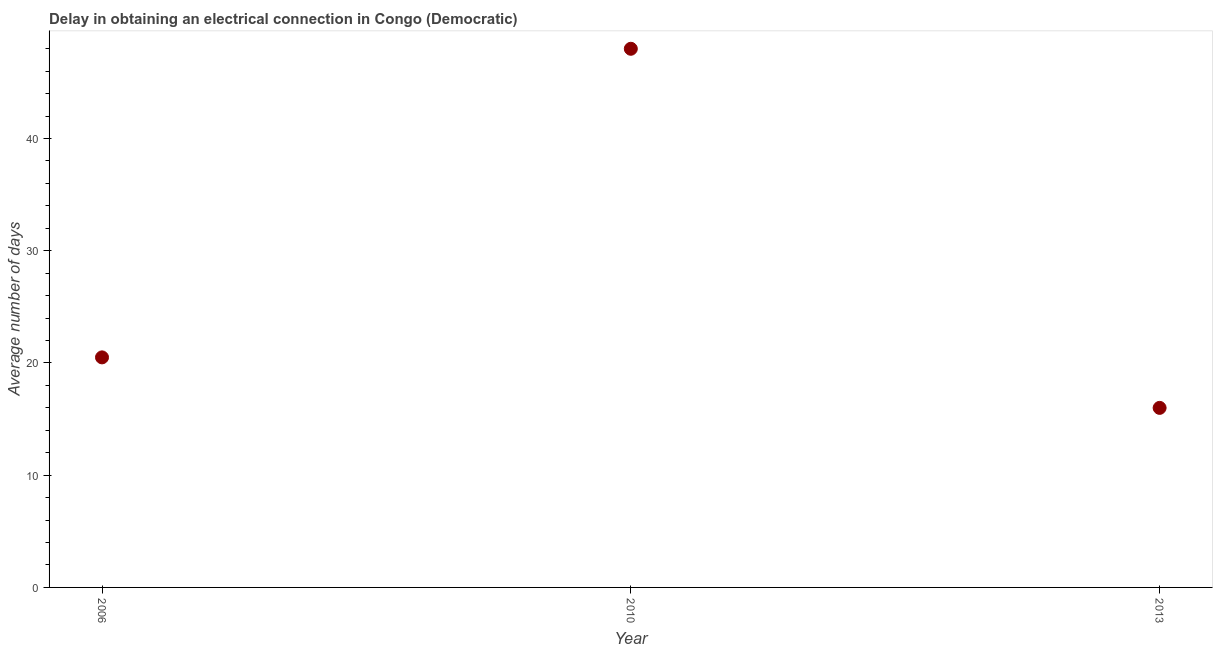What is the dalay in electrical connection in 2013?
Keep it short and to the point. 16. In which year was the dalay in electrical connection minimum?
Ensure brevity in your answer.  2013. What is the sum of the dalay in electrical connection?
Offer a very short reply. 84.5. What is the average dalay in electrical connection per year?
Give a very brief answer. 28.17. Is the dalay in electrical connection in 2006 less than that in 2013?
Keep it short and to the point. No. Is the difference between the dalay in electrical connection in 2006 and 2010 greater than the difference between any two years?
Give a very brief answer. No. What is the difference between the highest and the second highest dalay in electrical connection?
Keep it short and to the point. 27.5. What is the difference between the highest and the lowest dalay in electrical connection?
Offer a terse response. 32. What is the difference between two consecutive major ticks on the Y-axis?
Ensure brevity in your answer.  10. What is the title of the graph?
Keep it short and to the point. Delay in obtaining an electrical connection in Congo (Democratic). What is the label or title of the Y-axis?
Your response must be concise. Average number of days. What is the Average number of days in 2010?
Your answer should be very brief. 48. What is the Average number of days in 2013?
Offer a terse response. 16. What is the difference between the Average number of days in 2006 and 2010?
Your answer should be compact. -27.5. What is the difference between the Average number of days in 2010 and 2013?
Ensure brevity in your answer.  32. What is the ratio of the Average number of days in 2006 to that in 2010?
Make the answer very short. 0.43. What is the ratio of the Average number of days in 2006 to that in 2013?
Keep it short and to the point. 1.28. What is the ratio of the Average number of days in 2010 to that in 2013?
Provide a succinct answer. 3. 